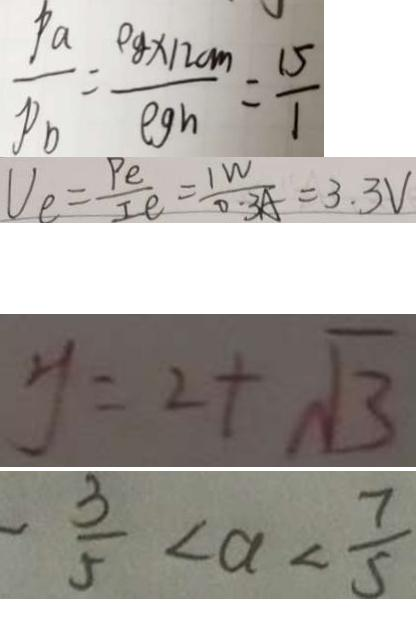Convert formula to latex. <formula><loc_0><loc_0><loc_500><loc_500>\frac { P a } { P _ { b } } = \frac { \rho g \times 1 2 c m } { \rho g h } = \frac { 1 5 } { 1 } 
 V _ { e } = \frac { P e } { I e } = \frac { 1 W } { 0 . 3 A } = 3 . 3 V 
 y = 2 + \sqrt { 3 } 
 - \frac { 3 } { 5 } < a < \frac { 7 } { 5 }</formula> 